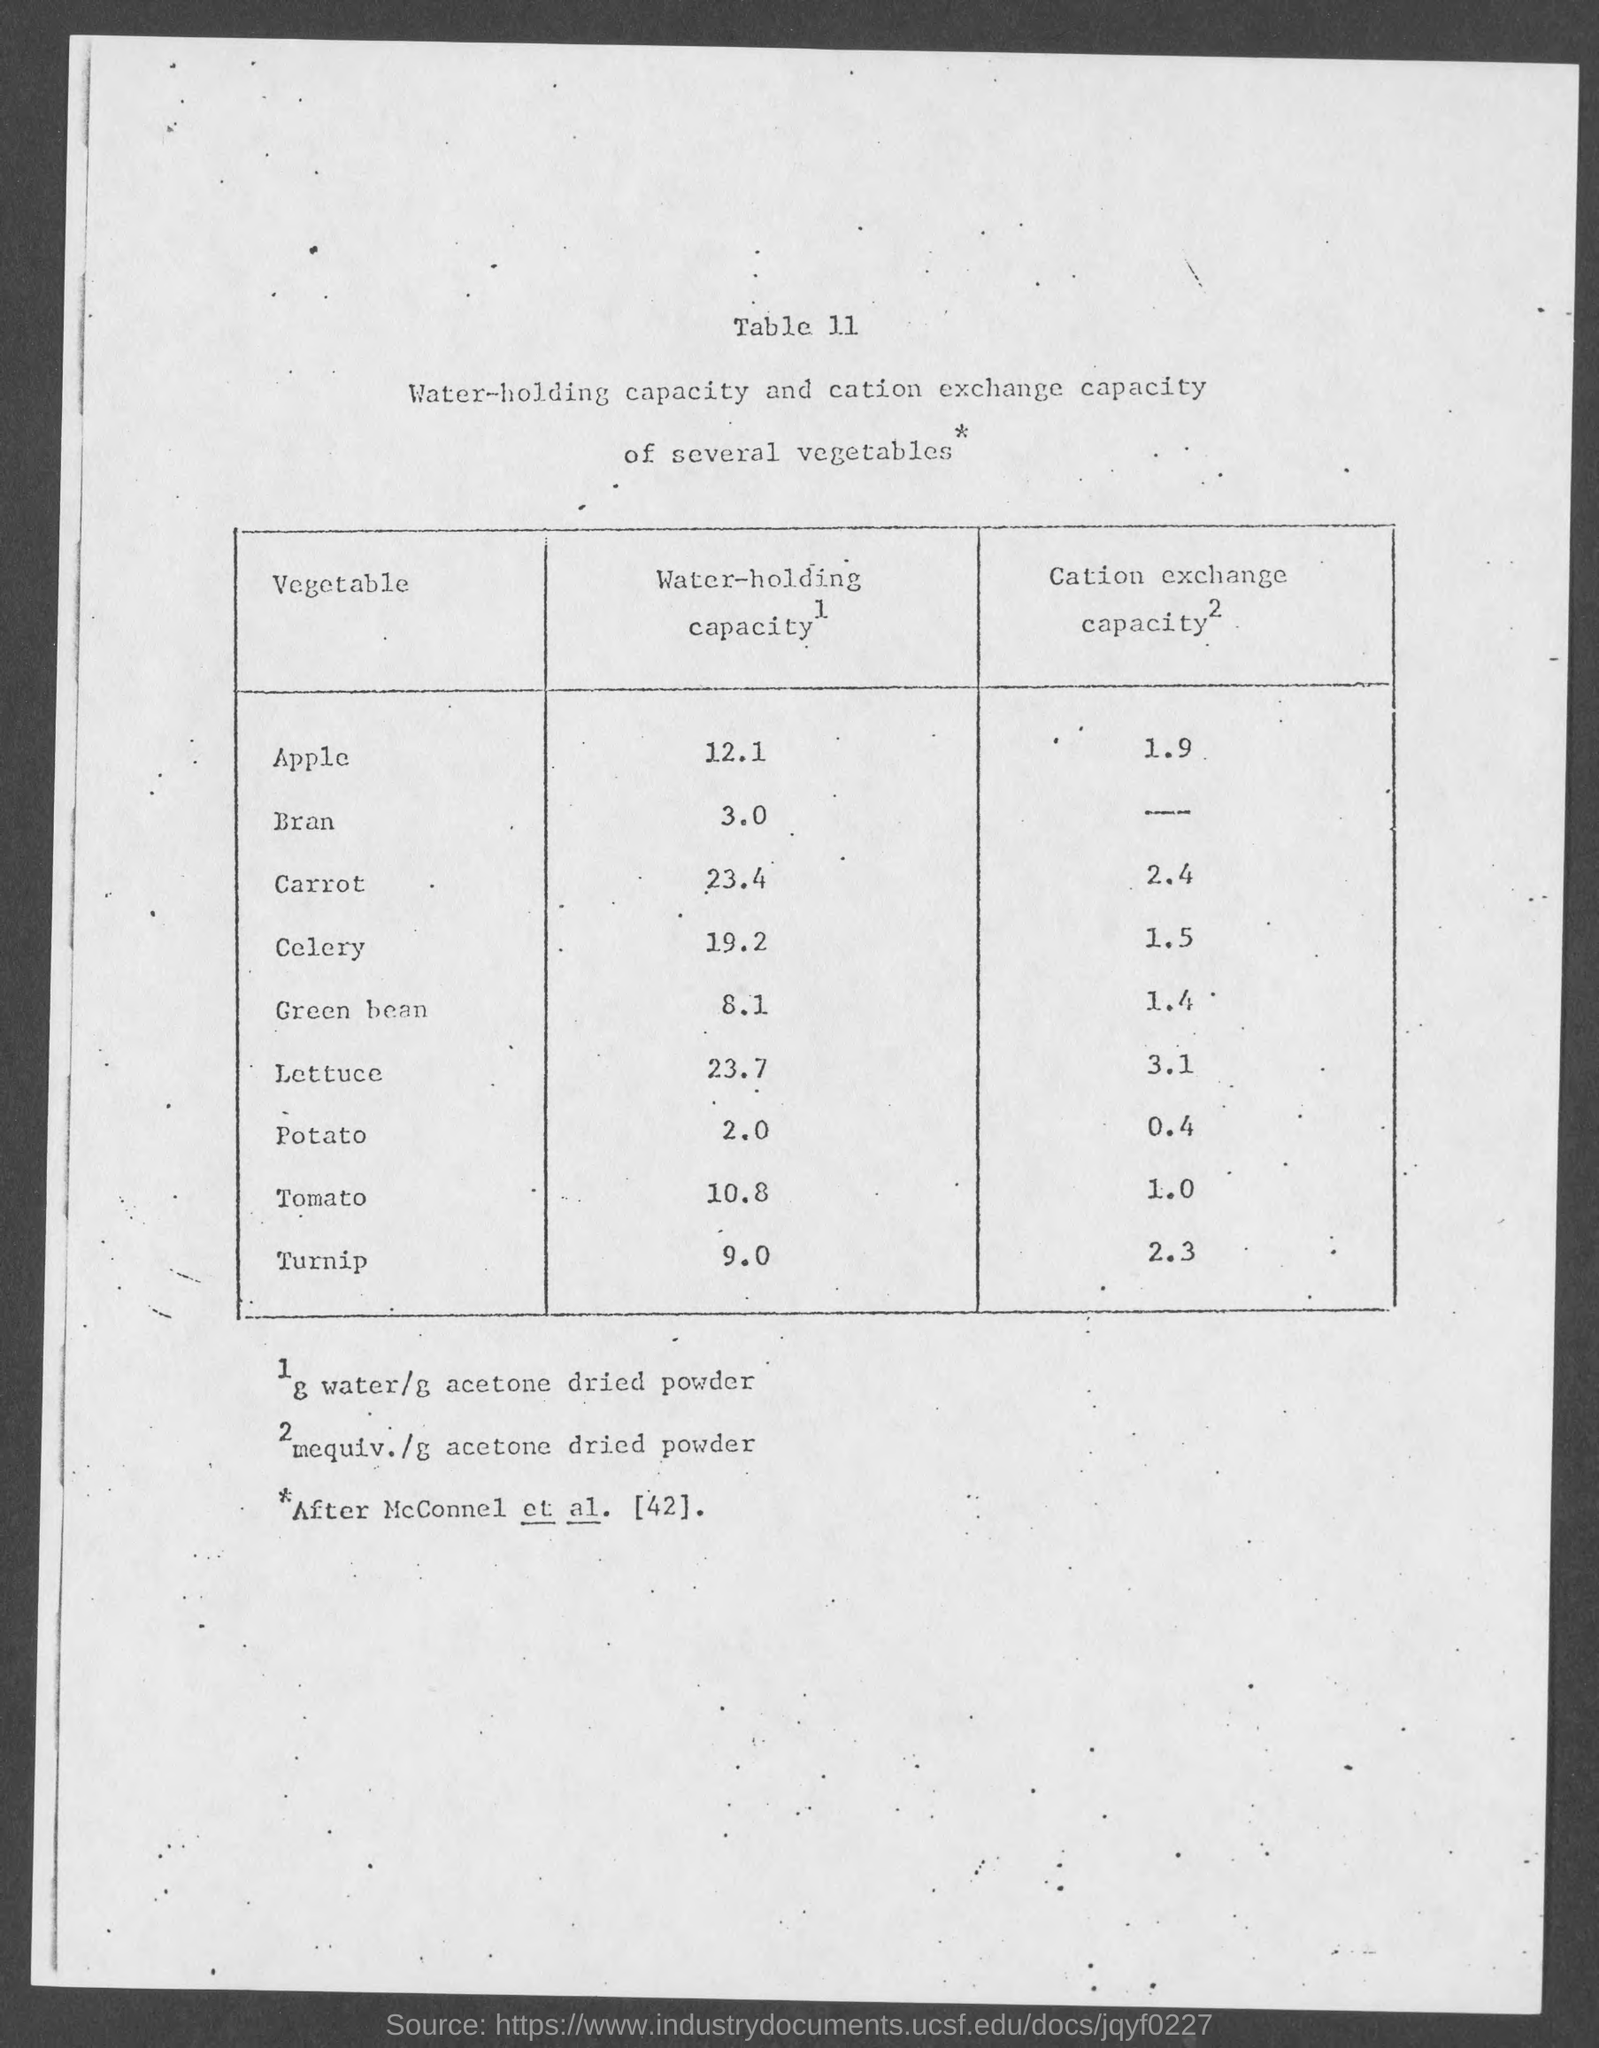What is the water holding capacity for apple ?
Your answer should be compact. 12.1. What is the cation exchange capacity for apple ?
Give a very brief answer. 1.9. What is  the water- holding capacity for bran ?
Offer a terse response. 3.0. What is the water holding capacity for carrot ?
Keep it short and to the point. 23.4. What is the cation exchange capacity for celery ?
Your response must be concise. 1.5. What is the water holding capacity for celery ?
Keep it short and to the point. 19.2. What is the cation exchange capacity for potato ?
Offer a terse response. 0.4. What is the water-holding capacity for tomato ?
Your response must be concise. 10.8. What is the cation exchange capacity for green beam ?
Your response must be concise. 1.4. What is the water-holding capacity for turnip ?
Provide a succinct answer. 9.0. 